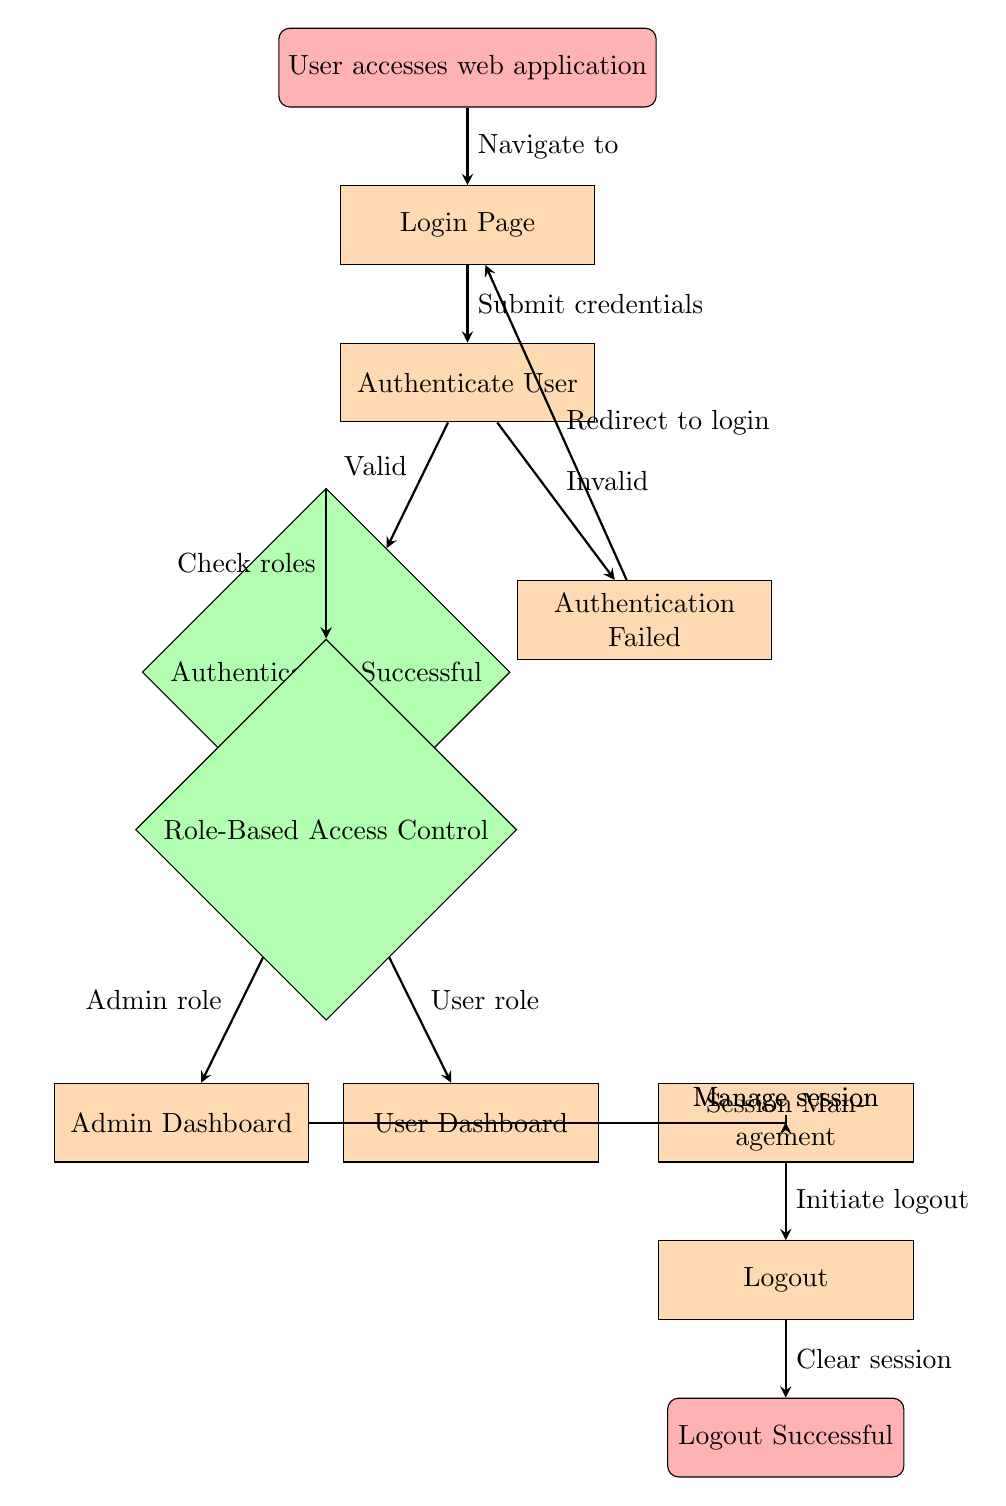What is the first step when a user accesses the web application? The first step is represented by the "User accesses web application" node, which is where the flow begins when a user navigates to the application.
Answer: User accesses web application What happens after the Login Page? After the "Login Page," the next step in the flow is to "Authenticate User," where the application attempts to verify the user's credentials.
Answer: Authenticate User How many decision nodes are in the diagram? The diagram contains two decision nodes: "Authentication Successful" and "Role-Based Access Control."
Answer: 2 What role leads to the Admin Dashboard? The role that leads to the "Admin Dashboard" is the "Admin role," which is checked after successful authentication and role evaluation.
Answer: Admin role If authentication fails, where does the user go next? If authentication fails, the user is redirected to the "Login Page" again as indicated by the flow from the "Authentication Failed" process.
Answer: Login Page What is the last step in the session management process? The last step in the session management process is "Logout," which is indicated as the action taken after managing the sessions for either the admin or the user.
Answer: Logout At what point does the user check their roles? The user checks their roles after successful authentication, represented by the "Check roles" arrow from the "Authentication Successful" decision node to the "Role-Based Access Control" decision node.
Answer: Check roles How does the flow return to the Login Page after authentication failure? The flow returns to the "Login Page" from "Authentication Failed" via the arrow labeled "Redirect to login," indicating the user's next action after failing to authenticate.
Answer: Redirect to login Which process handles the session after role determination? The process that handles the session after role determination is "Session Management," which follows the "Role-Based Access Control" decision node and is common for both admin and user roles.
Answer: Session Management 